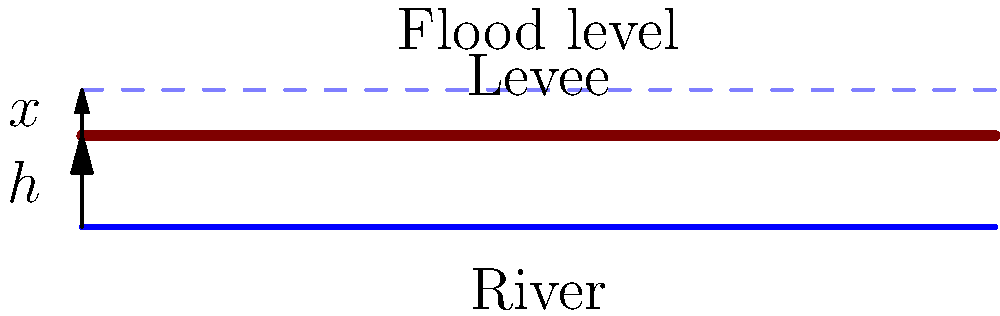The diagram shows a cross-section of a proposed flood control system for the Ocmulgee River in Macon, Georgia. The levee height is $h$ meters above the normal river level. If the 100-year flood level is expected to be $x$ meters above the levee, what is the minimum total height of the flood control system required to protect against the 100-year flood? To determine the minimum total height of the flood control system, we need to add the height of the levee above the normal river level and the height of the expected flood level above the levee. Here's how we calculate it:

1. Height of the levee above normal river level: $h$ meters
2. Height of the expected flood level above the levee: $x$ meters
3. Total height required = Levee height + Additional flood height
4. Mathematically, this can be expressed as: Total height = $h + x$ meters

Therefore, the minimum total height of the flood control system required to protect against the 100-year flood is the sum of the levee height ($h$) and the additional height needed to accommodate the flood level above the levee ($x$).
Answer: $h + x$ meters 